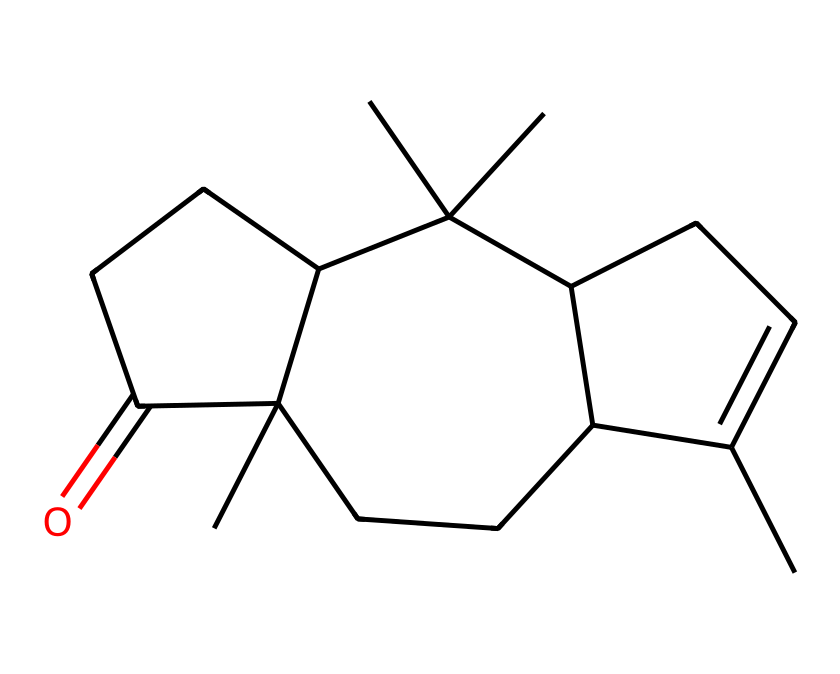how many carbon atoms are in this compound? By examining the SMILES notation, we can count the number of carbon (C) symbols present. In this case, there are 15 carbon atoms.
Answer: 15 how many rings are present in this compound? The chemical structure indicates the presence of fused rings, which can be identified by the arrangement of the carbon atoms. From the SMILES, there are three interconnected rings.
Answer: 3 what type of compound is this? The arrangement of the carbon atoms and the presence of cyclic structures indicate that this is a cage compound, typical for terpenes and related structures.
Answer: cage compound what functional group is involved in this molecule? Looking at the structure, there is a carbonyl group (C=O) noticeable in the ketone functional group, which affects its reactivity.
Answer: ketone which type of cage structure is evident in this chemical? The molecule reflects a specific cage-type configuration found in the chemical family of terpenoids, indicating its structural complexity.
Answer: terpenoid what is the total number of hydrogen atoms in this compound? To find the number of hydrogen atoms, we consider the general formula for carbons in a saturated compound (CnH2n+2), modified for rings and the presence of the carbonyl. After analysis, there are 24 hydrogen atoms.
Answer: 24 